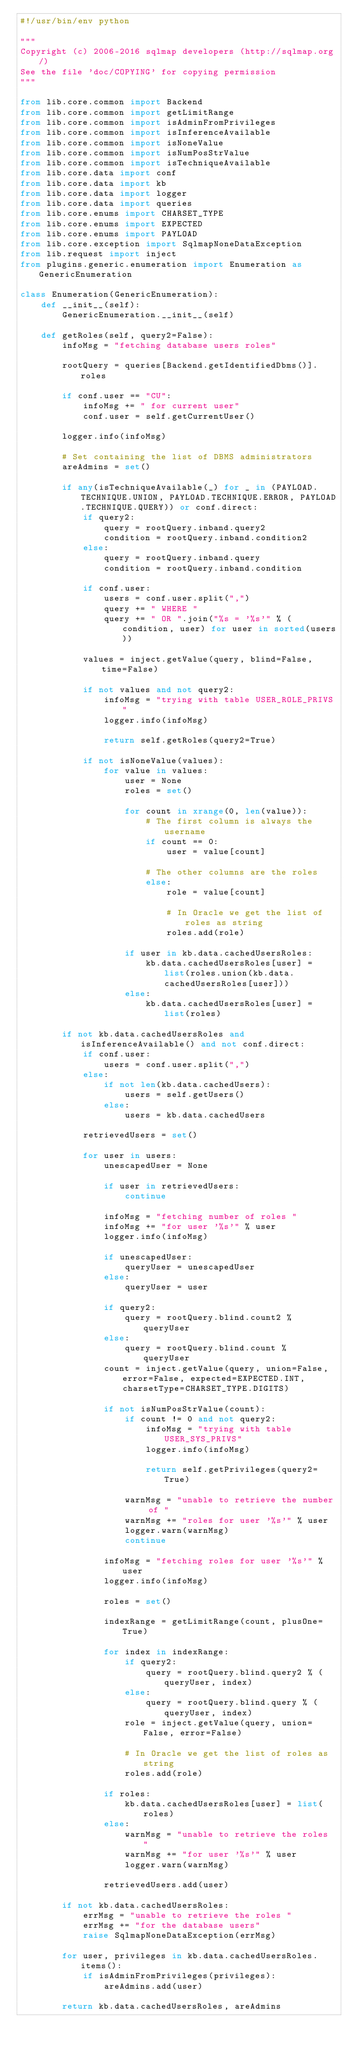<code> <loc_0><loc_0><loc_500><loc_500><_Python_>#!/usr/bin/env python

"""
Copyright (c) 2006-2016 sqlmap developers (http://sqlmap.org/)
See the file 'doc/COPYING' for copying permission
"""

from lib.core.common import Backend
from lib.core.common import getLimitRange
from lib.core.common import isAdminFromPrivileges
from lib.core.common import isInferenceAvailable
from lib.core.common import isNoneValue
from lib.core.common import isNumPosStrValue
from lib.core.common import isTechniqueAvailable
from lib.core.data import conf
from lib.core.data import kb
from lib.core.data import logger
from lib.core.data import queries
from lib.core.enums import CHARSET_TYPE
from lib.core.enums import EXPECTED
from lib.core.enums import PAYLOAD
from lib.core.exception import SqlmapNoneDataException
from lib.request import inject
from plugins.generic.enumeration import Enumeration as GenericEnumeration

class Enumeration(GenericEnumeration):
    def __init__(self):
        GenericEnumeration.__init__(self)

    def getRoles(self, query2=False):
        infoMsg = "fetching database users roles"

        rootQuery = queries[Backend.getIdentifiedDbms()].roles

        if conf.user == "CU":
            infoMsg += " for current user"
            conf.user = self.getCurrentUser()

        logger.info(infoMsg)

        # Set containing the list of DBMS administrators
        areAdmins = set()

        if any(isTechniqueAvailable(_) for _ in (PAYLOAD.TECHNIQUE.UNION, PAYLOAD.TECHNIQUE.ERROR, PAYLOAD.TECHNIQUE.QUERY)) or conf.direct:
            if query2:
                query = rootQuery.inband.query2
                condition = rootQuery.inband.condition2
            else:
                query = rootQuery.inband.query
                condition = rootQuery.inband.condition

            if conf.user:
                users = conf.user.split(",")
                query += " WHERE "
                query += " OR ".join("%s = '%s'" % (condition, user) for user in sorted(users))

            values = inject.getValue(query, blind=False, time=False)

            if not values and not query2:
                infoMsg = "trying with table USER_ROLE_PRIVS"
                logger.info(infoMsg)

                return self.getRoles(query2=True)

            if not isNoneValue(values):
                for value in values:
                    user = None
                    roles = set()

                    for count in xrange(0, len(value)):
                        # The first column is always the username
                        if count == 0:
                            user = value[count]

                        # The other columns are the roles
                        else:
                            role = value[count]

                            # In Oracle we get the list of roles as string
                            roles.add(role)

                    if user in kb.data.cachedUsersRoles:
                        kb.data.cachedUsersRoles[user] = list(roles.union(kb.data.cachedUsersRoles[user]))
                    else:
                        kb.data.cachedUsersRoles[user] = list(roles)

        if not kb.data.cachedUsersRoles and isInferenceAvailable() and not conf.direct:
            if conf.user:
                users = conf.user.split(",")
            else:
                if not len(kb.data.cachedUsers):
                    users = self.getUsers()
                else:
                    users = kb.data.cachedUsers

            retrievedUsers = set()

            for user in users:
                unescapedUser = None

                if user in retrievedUsers:
                    continue

                infoMsg = "fetching number of roles "
                infoMsg += "for user '%s'" % user
                logger.info(infoMsg)

                if unescapedUser:
                    queryUser = unescapedUser
                else:
                    queryUser = user

                if query2:
                    query = rootQuery.blind.count2 % queryUser
                else:
                    query = rootQuery.blind.count % queryUser
                count = inject.getValue(query, union=False, error=False, expected=EXPECTED.INT, charsetType=CHARSET_TYPE.DIGITS)

                if not isNumPosStrValue(count):
                    if count != 0 and not query2:
                        infoMsg = "trying with table USER_SYS_PRIVS"
                        logger.info(infoMsg)

                        return self.getPrivileges(query2=True)

                    warnMsg = "unable to retrieve the number of "
                    warnMsg += "roles for user '%s'" % user
                    logger.warn(warnMsg)
                    continue

                infoMsg = "fetching roles for user '%s'" % user
                logger.info(infoMsg)

                roles = set()

                indexRange = getLimitRange(count, plusOne=True)

                for index in indexRange:
                    if query2:
                        query = rootQuery.blind.query2 % (queryUser, index)
                    else:
                        query = rootQuery.blind.query % (queryUser, index)
                    role = inject.getValue(query, union=False, error=False)

                    # In Oracle we get the list of roles as string
                    roles.add(role)

                if roles:
                    kb.data.cachedUsersRoles[user] = list(roles)
                else:
                    warnMsg = "unable to retrieve the roles "
                    warnMsg += "for user '%s'" % user
                    logger.warn(warnMsg)

                retrievedUsers.add(user)

        if not kb.data.cachedUsersRoles:
            errMsg = "unable to retrieve the roles "
            errMsg += "for the database users"
            raise SqlmapNoneDataException(errMsg)

        for user, privileges in kb.data.cachedUsersRoles.items():
            if isAdminFromPrivileges(privileges):
                areAdmins.add(user)

        return kb.data.cachedUsersRoles, areAdmins
</code> 